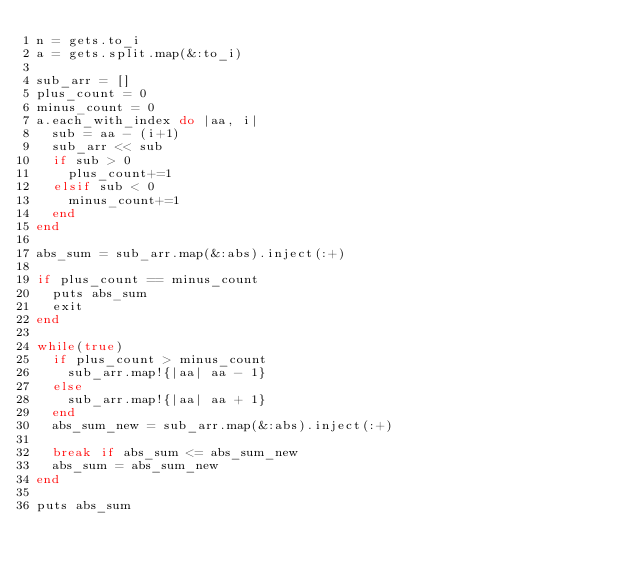Convert code to text. <code><loc_0><loc_0><loc_500><loc_500><_Ruby_>n = gets.to_i
a = gets.split.map(&:to_i)

sub_arr = []
plus_count = 0
minus_count = 0
a.each_with_index do |aa, i|
  sub = aa - (i+1)
  sub_arr << sub
  if sub > 0
    plus_count+=1
  elsif sub < 0
    minus_count+=1
  end
end

abs_sum = sub_arr.map(&:abs).inject(:+)

if plus_count == minus_count
  puts abs_sum
  exit
end

while(true)
  if plus_count > minus_count
    sub_arr.map!{|aa| aa - 1}
  else
    sub_arr.map!{|aa| aa + 1}
  end
  abs_sum_new = sub_arr.map(&:abs).inject(:+)

  break if abs_sum <= abs_sum_new
  abs_sum = abs_sum_new
end

puts abs_sum
</code> 